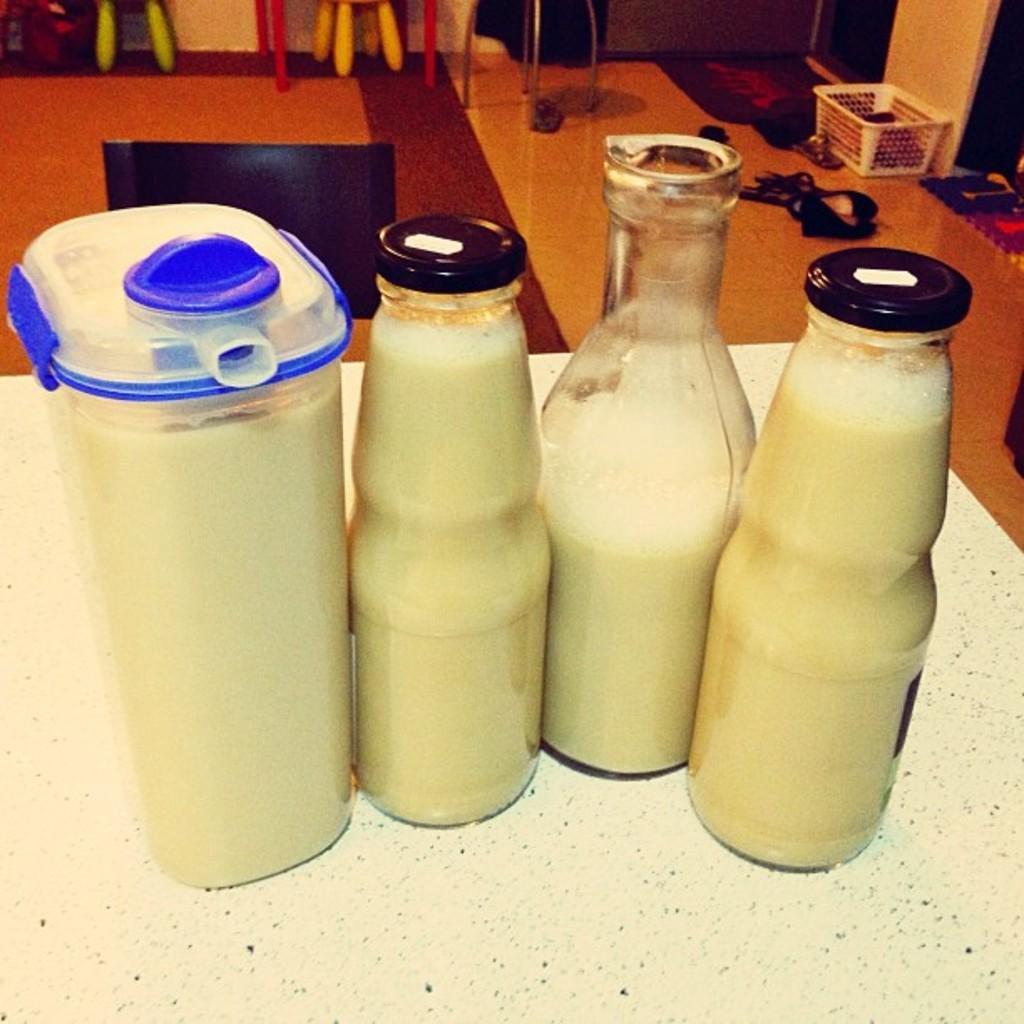In one or two sentences, can you explain what this image depicts? In this picture there are bottles on the table and there is drink in the bottles. At the back there is a basket and there are chairs and there are objects. At the bottom there is a mat and there are footwear's on the floor. 